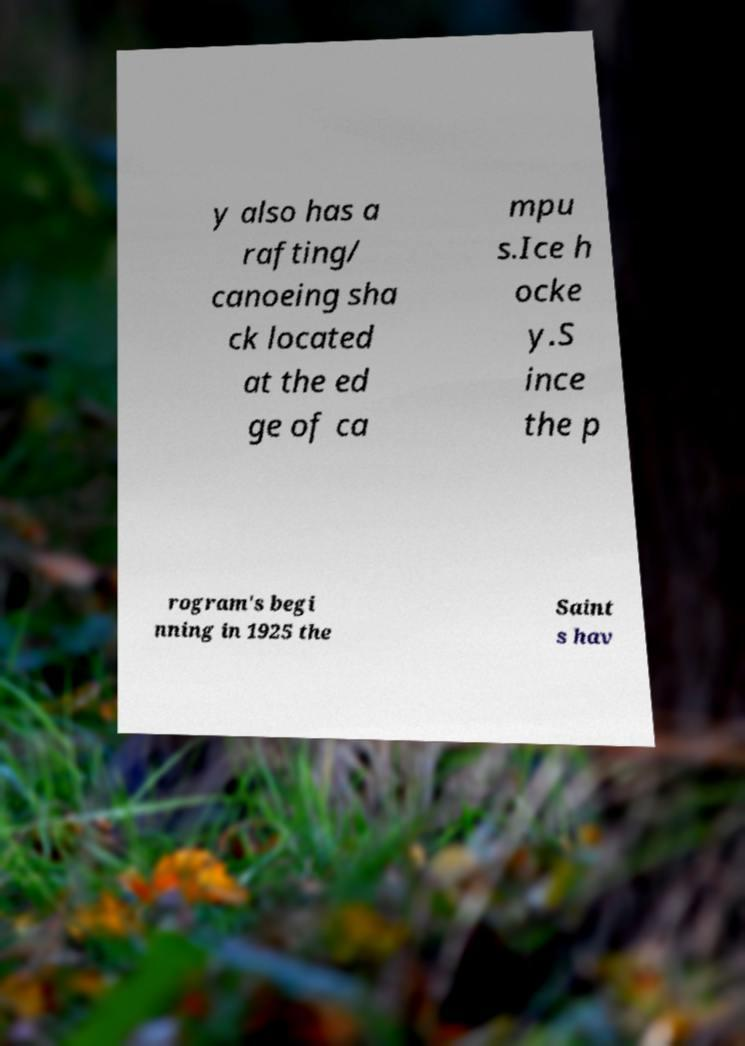Can you accurately transcribe the text from the provided image for me? y also has a rafting/ canoeing sha ck located at the ed ge of ca mpu s.Ice h ocke y.S ince the p rogram's begi nning in 1925 the Saint s hav 